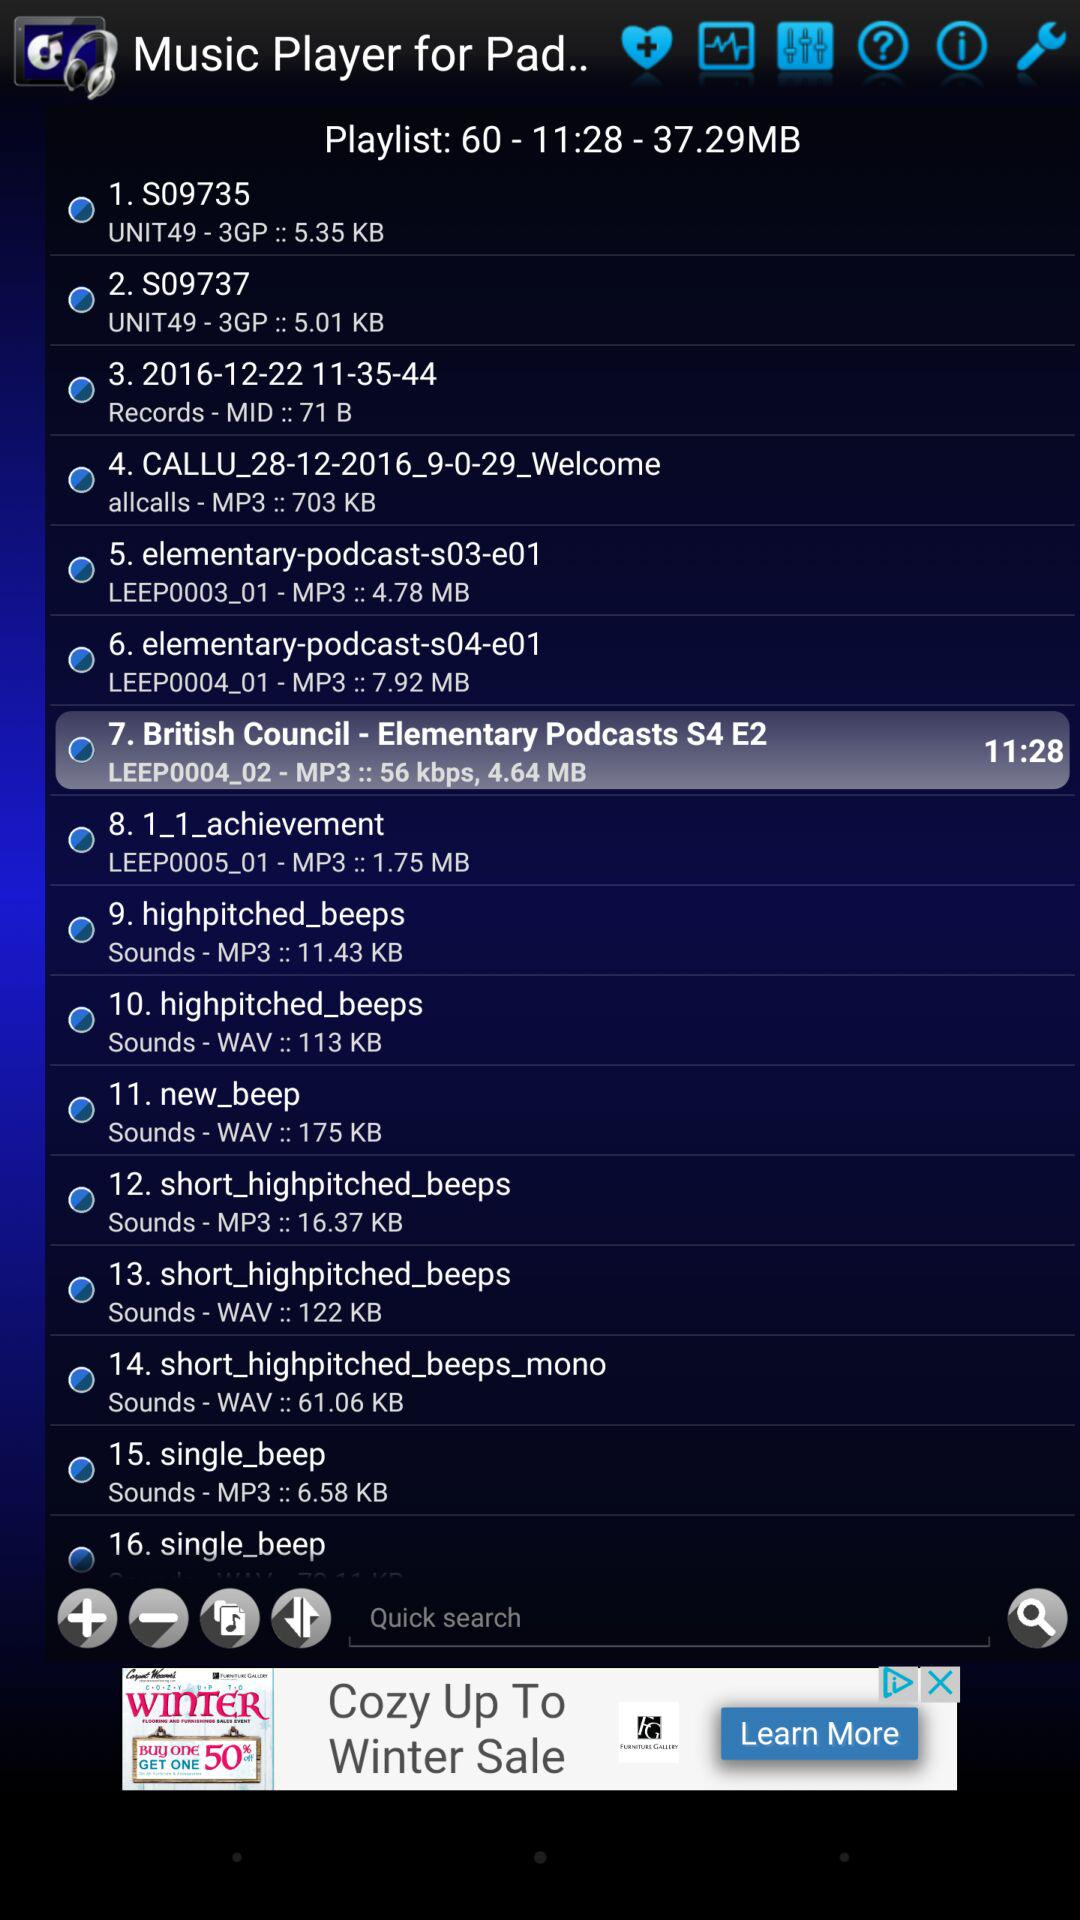Which playlists are in the favorites?
When the provided information is insufficient, respond with <no answer>. <no answer> 